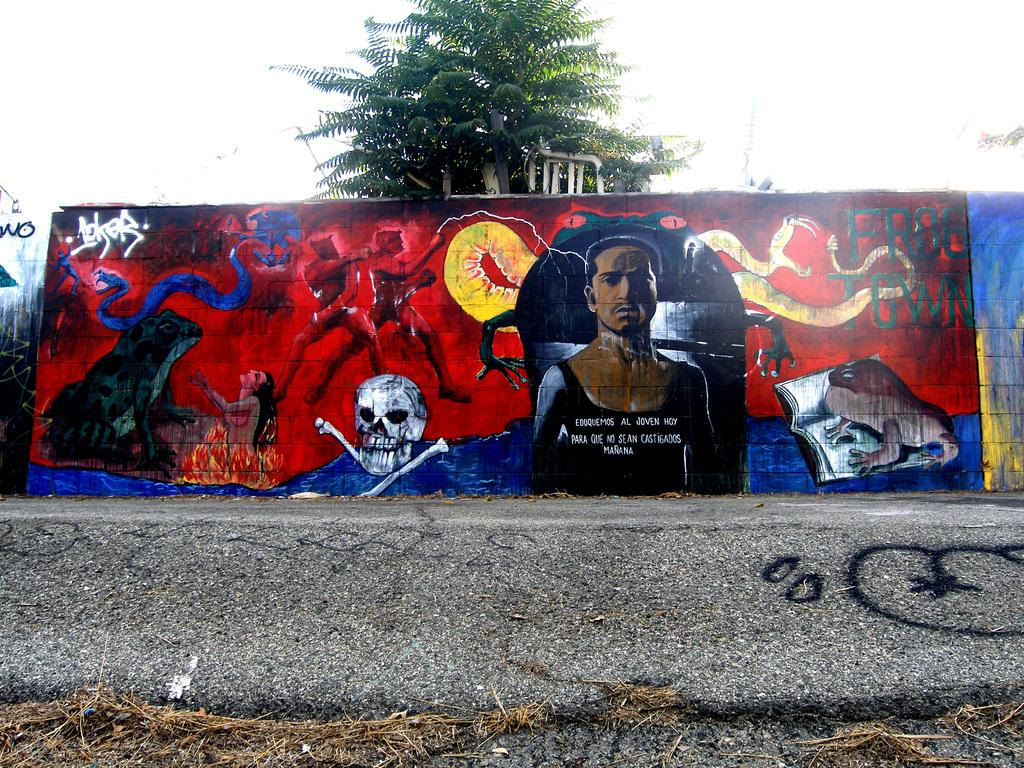What can be seen on the wall in the image? There are pictures painted on the wall. What type of natural elements are present in the image? There are trees in the image. What type of man-made structure is visible in the image? There is a road in the image. What type of landscaping is present in the image? There is a lawn in the image. What type of utensils are visible in the image? There are straws in the image. What is visible in the upper part of the image? The sky is visible in the image. How many bikes are smashed on the road in the image? There are no bikes present in the image, let alone any smashed ones. What type of fork can be seen in the image? There is no fork present in the image. 